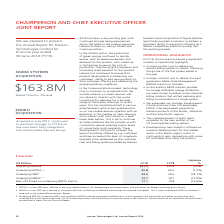According to Hansen Technologies's financial document, What was the operating revenue for 2019? Based on the financial document, the answer is $231.3 million. Also, Why did the operating revenue increase? Based on the financial document, the answer is With Sigma contributing $5.0 million of revenue in June (the first month since acquisition), revenues for the remainder of Hansen excluding Sigma were $4.5 million lower. This decline was a result of lower non-recurring revenues, due primarily to both lower one-off licence fees and reduced project work following the large body of work completed in the first half of FY18 associated with implementing Power of Choice in Australia.. Also, What was the underlying EBITDA for 2019? According to the financial document, 55.8 (in millions). The relevant text states: "Underlying EBITDA 1, 3 55.8 60.0 (7.0%)..." Also, can you calculate: What was the average operating revenue for the two FYs? To answer this question, I need to perform calculations using the financial data. The calculation is: (231.3 + 230.8)/2 , which equals 231.05 (in millions). This is based on the information: "Operating revenue 231.3 230.8 0.2% Operating revenue 231.3 230.8 0.2%..." The key data points involved are: 230.8, 231.3. Also, can you calculate: What was the difference between EBITDA and NPAT for FY18? Based on the calculation: 60.0 - 29.5 , the result is 30.5 (in millions). This is based on the information: "Underlying NPAT 3 24.0 29.5 (18.7%) Underlying EBITDA 1, 3 55.8 60.0 (7.0%)..." The key data points involved are: 29.5, 60.0. Also, can you calculate: What was the average basic EPS for the 2 FYs? To answer this question, I need to perform calculations using the financial data. The calculation is: (17.1 + 19.8)/2 , which equals 18.45. This is based on the information: "asic EPS based on underlying NPATA (cents) 2 17.1 19.8 (13.6%) Basic EPS based on underlying NPATA (cents) 2 17.1 19.8 (13.6%)..." The key data points involved are: 17.1, 19.8. 